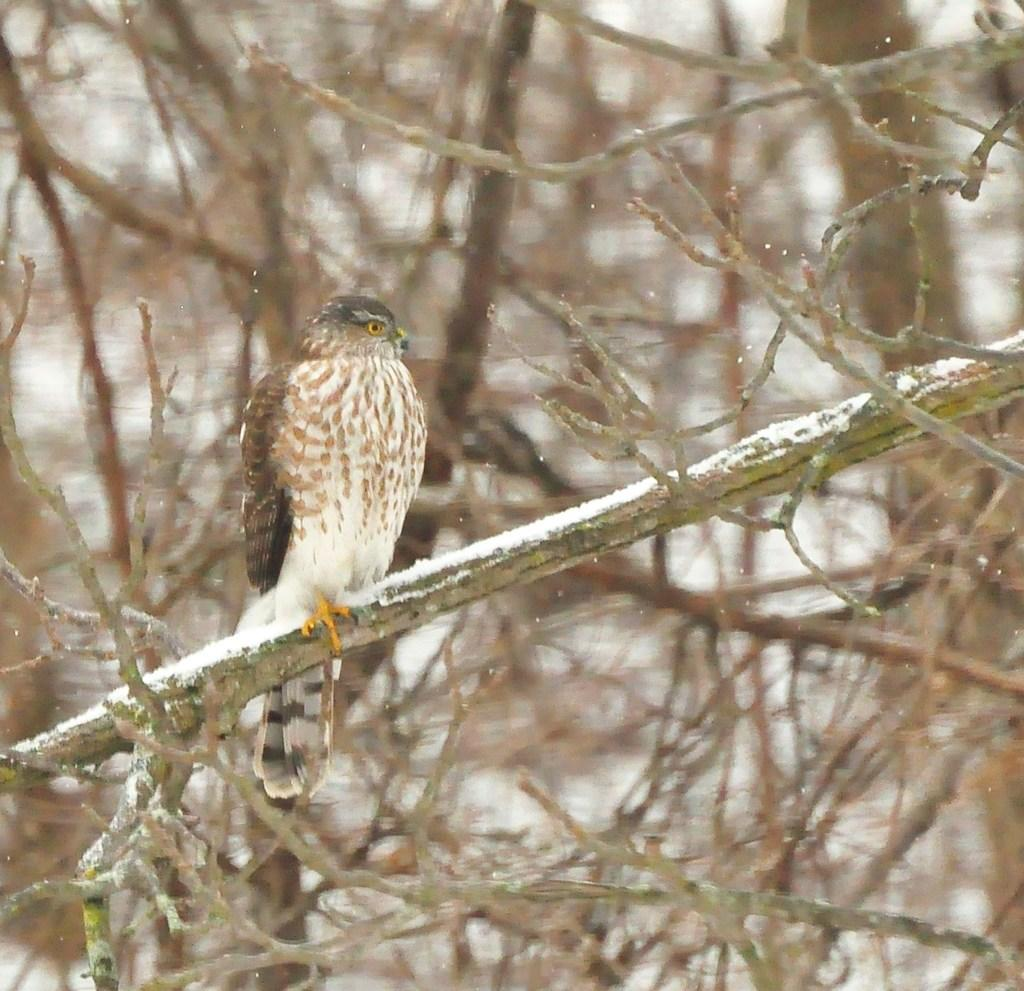What type of animal can be seen in the image? There is a bird in the image. Where is the bird located? The bird is on a tree. What type of collar is the bird wearing in the image? There is no collar present on the bird in the image. 